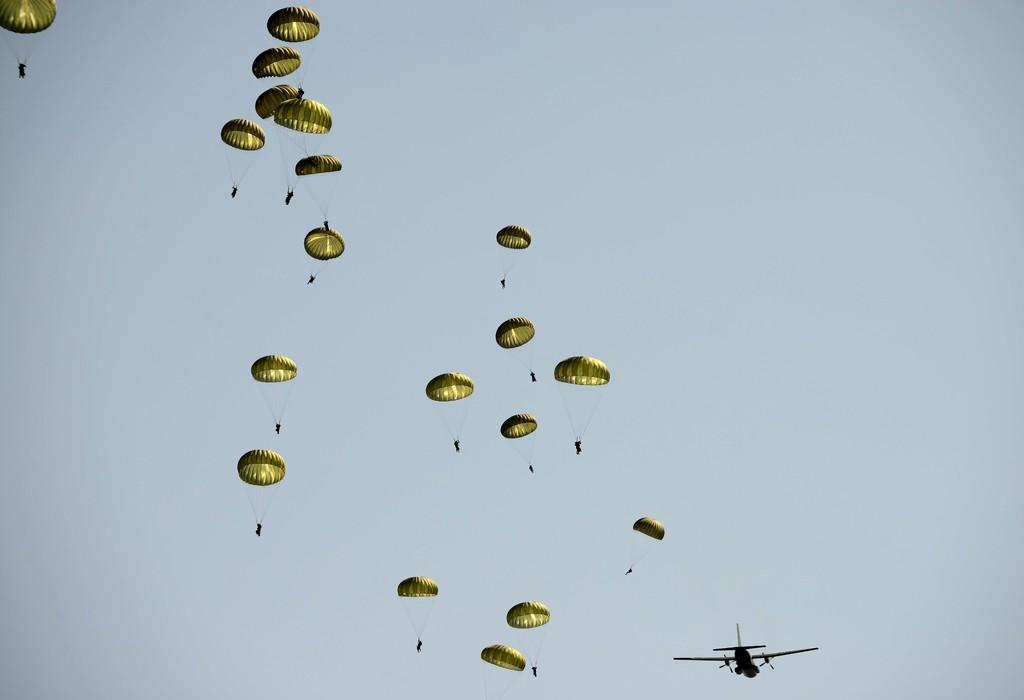What are the people in the image doing? The people in the image are skydiving with parachutes. What is the source of their descent in the image? The people are descending from an airplane that is flying in the image. What can be seen in the background of the image? The sky is visible in the image. How many rings can be seen on the parachutes in the image? There are no rings visible on the parachutes in the image. What type of beam is holding up the airplane in the image? There is no beam present in the image; the airplane is flying in the sky. 